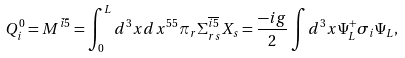Convert formula to latex. <formula><loc_0><loc_0><loc_500><loc_500>Q ^ { 0 } _ { i } = M ^ { \bar { i } \bar { 5 } } = \int ^ { L } _ { 0 } d ^ { 3 } x d x ^ { 5 } { ^ { 5 } \pi } _ { r } \Sigma ^ { \overline { i } \overline { 5 } } _ { r s } X _ { s } = \frac { - i g } { 2 } \int d ^ { 3 } x \Psi ^ { + } _ { L } \sigma _ { i } \Psi _ { L } ,</formula> 